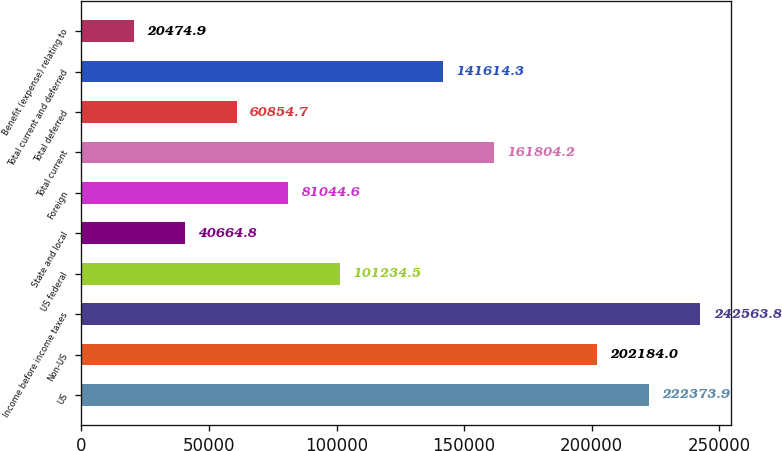Convert chart. <chart><loc_0><loc_0><loc_500><loc_500><bar_chart><fcel>US<fcel>Non-US<fcel>Income before income taxes<fcel>US federal<fcel>State and local<fcel>Foreign<fcel>Total current<fcel>Total deferred<fcel>Total current and deferred<fcel>Benefit (expense) relating to<nl><fcel>222374<fcel>202184<fcel>242564<fcel>101234<fcel>40664.8<fcel>81044.6<fcel>161804<fcel>60854.7<fcel>141614<fcel>20474.9<nl></chart> 